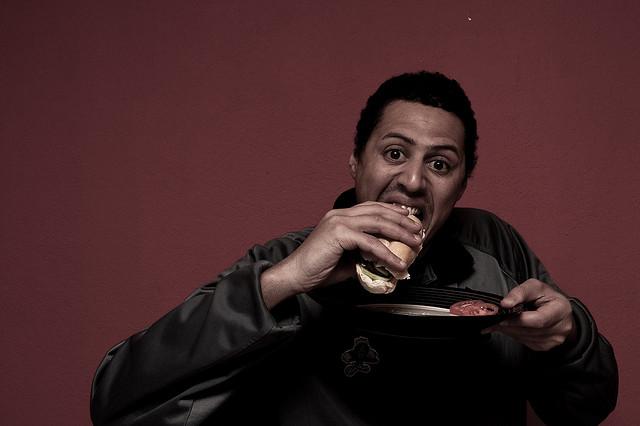What is the man holding?
Write a very short answer. Sandwich. What is in the man's hand?
Give a very brief answer. Sandwich. What is she holding?
Quick response, please. Sandwich. What is the man holding in his hand?
Keep it brief. Sandwich. What is in the mans mouth?
Short answer required. Sandwich. What are they are eating?
Short answer required. Sandwich. What is he eating the food off of?
Write a very short answer. Plate. Is the man holding the plate?
Quick response, please. Yes. What are they eating?
Give a very brief answer. Hot dog. Is this man cross-eyed?
Write a very short answer. No. What is the man holding in his right hand?
Keep it brief. Hot dog. Is this man hungry?
Short answer required. Yes. What is the person holding?
Keep it brief. Sandwich. What is this person eating?
Write a very short answer. Sandwich. What color is the wall?
Answer briefly. Red. What is the person licking?
Concise answer only. Sandwich. What is the person doing?
Be succinct. Eating. Does the man have a beard?
Concise answer only. No. Is this man married?
Quick response, please. No. What daily activity is occurring?
Keep it brief. Eating. What is the man doing?
Keep it brief. Eating. Is this man shaving or brushing his teeth?
Short answer required. No. What taste receptor will this food activate?
Give a very brief answer. Taste buds. How many fruits are there?
Keep it brief. 1. What color is the man's hair?
Short answer required. Black. What is he holding?
Keep it brief. Sandwich. 